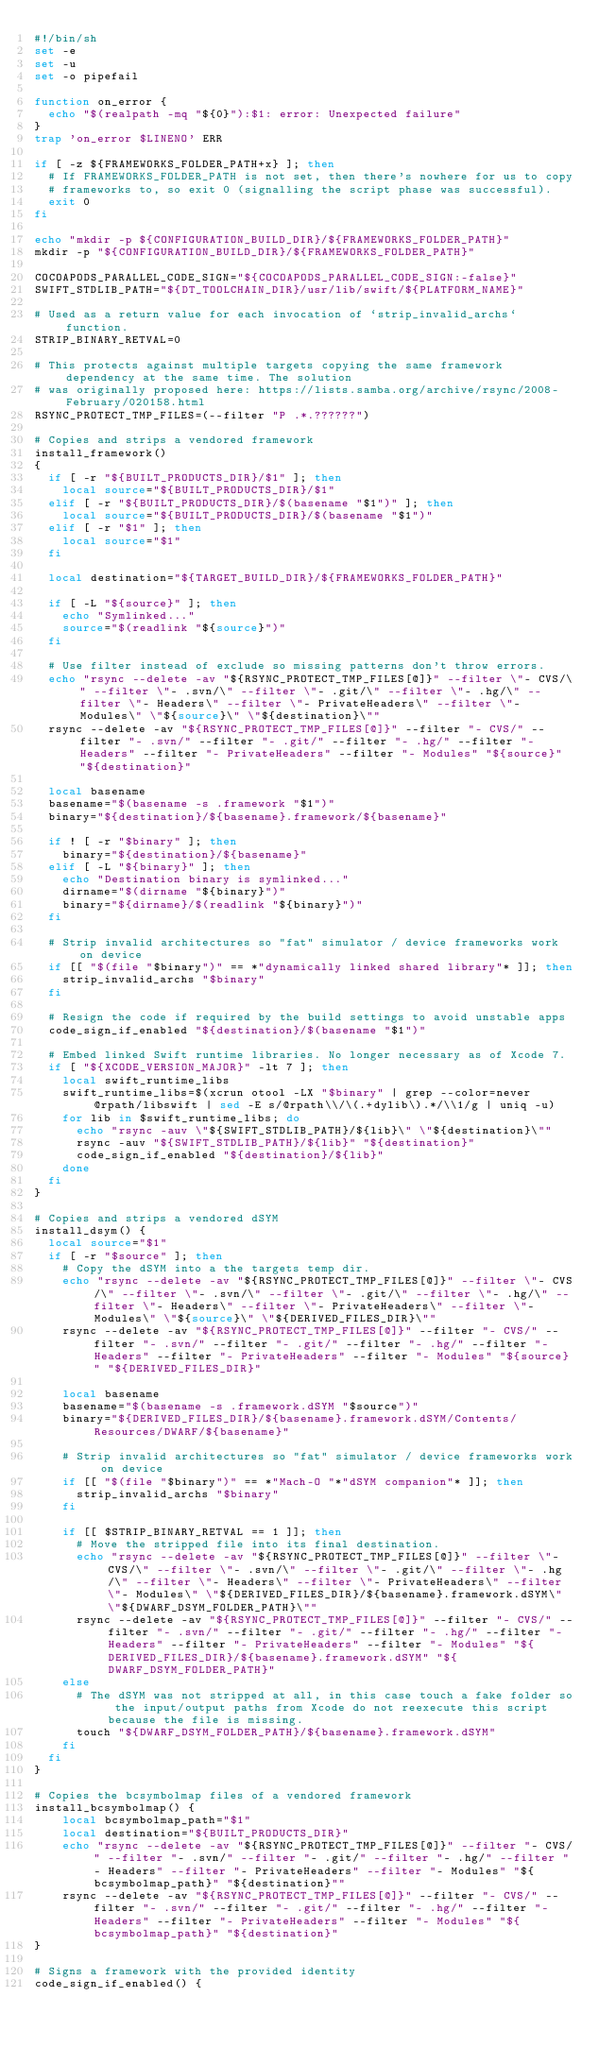<code> <loc_0><loc_0><loc_500><loc_500><_Bash_>#!/bin/sh
set -e
set -u
set -o pipefail

function on_error {
  echo "$(realpath -mq "${0}"):$1: error: Unexpected failure"
}
trap 'on_error $LINENO' ERR

if [ -z ${FRAMEWORKS_FOLDER_PATH+x} ]; then
  # If FRAMEWORKS_FOLDER_PATH is not set, then there's nowhere for us to copy
  # frameworks to, so exit 0 (signalling the script phase was successful).
  exit 0
fi

echo "mkdir -p ${CONFIGURATION_BUILD_DIR}/${FRAMEWORKS_FOLDER_PATH}"
mkdir -p "${CONFIGURATION_BUILD_DIR}/${FRAMEWORKS_FOLDER_PATH}"

COCOAPODS_PARALLEL_CODE_SIGN="${COCOAPODS_PARALLEL_CODE_SIGN:-false}"
SWIFT_STDLIB_PATH="${DT_TOOLCHAIN_DIR}/usr/lib/swift/${PLATFORM_NAME}"

# Used as a return value for each invocation of `strip_invalid_archs` function.
STRIP_BINARY_RETVAL=0

# This protects against multiple targets copying the same framework dependency at the same time. The solution
# was originally proposed here: https://lists.samba.org/archive/rsync/2008-February/020158.html
RSYNC_PROTECT_TMP_FILES=(--filter "P .*.??????")

# Copies and strips a vendored framework
install_framework()
{
  if [ -r "${BUILT_PRODUCTS_DIR}/$1" ]; then
    local source="${BUILT_PRODUCTS_DIR}/$1"
  elif [ -r "${BUILT_PRODUCTS_DIR}/$(basename "$1")" ]; then
    local source="${BUILT_PRODUCTS_DIR}/$(basename "$1")"
  elif [ -r "$1" ]; then
    local source="$1"
  fi

  local destination="${TARGET_BUILD_DIR}/${FRAMEWORKS_FOLDER_PATH}"

  if [ -L "${source}" ]; then
    echo "Symlinked..."
    source="$(readlink "${source}")"
  fi

  # Use filter instead of exclude so missing patterns don't throw errors.
  echo "rsync --delete -av "${RSYNC_PROTECT_TMP_FILES[@]}" --filter \"- CVS/\" --filter \"- .svn/\" --filter \"- .git/\" --filter \"- .hg/\" --filter \"- Headers\" --filter \"- PrivateHeaders\" --filter \"- Modules\" \"${source}\" \"${destination}\""
  rsync --delete -av "${RSYNC_PROTECT_TMP_FILES[@]}" --filter "- CVS/" --filter "- .svn/" --filter "- .git/" --filter "- .hg/" --filter "- Headers" --filter "- PrivateHeaders" --filter "- Modules" "${source}" "${destination}"

  local basename
  basename="$(basename -s .framework "$1")"
  binary="${destination}/${basename}.framework/${basename}"

  if ! [ -r "$binary" ]; then
    binary="${destination}/${basename}"
  elif [ -L "${binary}" ]; then
    echo "Destination binary is symlinked..."
    dirname="$(dirname "${binary}")"
    binary="${dirname}/$(readlink "${binary}")"
  fi

  # Strip invalid architectures so "fat" simulator / device frameworks work on device
  if [[ "$(file "$binary")" == *"dynamically linked shared library"* ]]; then
    strip_invalid_archs "$binary"
  fi

  # Resign the code if required by the build settings to avoid unstable apps
  code_sign_if_enabled "${destination}/$(basename "$1")"

  # Embed linked Swift runtime libraries. No longer necessary as of Xcode 7.
  if [ "${XCODE_VERSION_MAJOR}" -lt 7 ]; then
    local swift_runtime_libs
    swift_runtime_libs=$(xcrun otool -LX "$binary" | grep --color=never @rpath/libswift | sed -E s/@rpath\\/\(.+dylib\).*/\\1/g | uniq -u)
    for lib in $swift_runtime_libs; do
      echo "rsync -auv \"${SWIFT_STDLIB_PATH}/${lib}\" \"${destination}\""
      rsync -auv "${SWIFT_STDLIB_PATH}/${lib}" "${destination}"
      code_sign_if_enabled "${destination}/${lib}"
    done
  fi
}

# Copies and strips a vendored dSYM
install_dsym() {
  local source="$1"
  if [ -r "$source" ]; then
    # Copy the dSYM into a the targets temp dir.
    echo "rsync --delete -av "${RSYNC_PROTECT_TMP_FILES[@]}" --filter \"- CVS/\" --filter \"- .svn/\" --filter \"- .git/\" --filter \"- .hg/\" --filter \"- Headers\" --filter \"- PrivateHeaders\" --filter \"- Modules\" \"${source}\" \"${DERIVED_FILES_DIR}\""
    rsync --delete -av "${RSYNC_PROTECT_TMP_FILES[@]}" --filter "- CVS/" --filter "- .svn/" --filter "- .git/" --filter "- .hg/" --filter "- Headers" --filter "- PrivateHeaders" --filter "- Modules" "${source}" "${DERIVED_FILES_DIR}"

    local basename
    basename="$(basename -s .framework.dSYM "$source")"
    binary="${DERIVED_FILES_DIR}/${basename}.framework.dSYM/Contents/Resources/DWARF/${basename}"

    # Strip invalid architectures so "fat" simulator / device frameworks work on device
    if [[ "$(file "$binary")" == *"Mach-O "*"dSYM companion"* ]]; then
      strip_invalid_archs "$binary"
    fi

    if [[ $STRIP_BINARY_RETVAL == 1 ]]; then
      # Move the stripped file into its final destination.
      echo "rsync --delete -av "${RSYNC_PROTECT_TMP_FILES[@]}" --filter \"- CVS/\" --filter \"- .svn/\" --filter \"- .git/\" --filter \"- .hg/\" --filter \"- Headers\" --filter \"- PrivateHeaders\" --filter \"- Modules\" \"${DERIVED_FILES_DIR}/${basename}.framework.dSYM\" \"${DWARF_DSYM_FOLDER_PATH}\""
      rsync --delete -av "${RSYNC_PROTECT_TMP_FILES[@]}" --filter "- CVS/" --filter "- .svn/" --filter "- .git/" --filter "- .hg/" --filter "- Headers" --filter "- PrivateHeaders" --filter "- Modules" "${DERIVED_FILES_DIR}/${basename}.framework.dSYM" "${DWARF_DSYM_FOLDER_PATH}"
    else
      # The dSYM was not stripped at all, in this case touch a fake folder so the input/output paths from Xcode do not reexecute this script because the file is missing.
      touch "${DWARF_DSYM_FOLDER_PATH}/${basename}.framework.dSYM"
    fi
  fi
}

# Copies the bcsymbolmap files of a vendored framework
install_bcsymbolmap() {
    local bcsymbolmap_path="$1"
    local destination="${BUILT_PRODUCTS_DIR}"
    echo "rsync --delete -av "${RSYNC_PROTECT_TMP_FILES[@]}" --filter "- CVS/" --filter "- .svn/" --filter "- .git/" --filter "- .hg/" --filter "- Headers" --filter "- PrivateHeaders" --filter "- Modules" "${bcsymbolmap_path}" "${destination}""
    rsync --delete -av "${RSYNC_PROTECT_TMP_FILES[@]}" --filter "- CVS/" --filter "- .svn/" --filter "- .git/" --filter "- .hg/" --filter "- Headers" --filter "- PrivateHeaders" --filter "- Modules" "${bcsymbolmap_path}" "${destination}"
}

# Signs a framework with the provided identity
code_sign_if_enabled() {</code> 